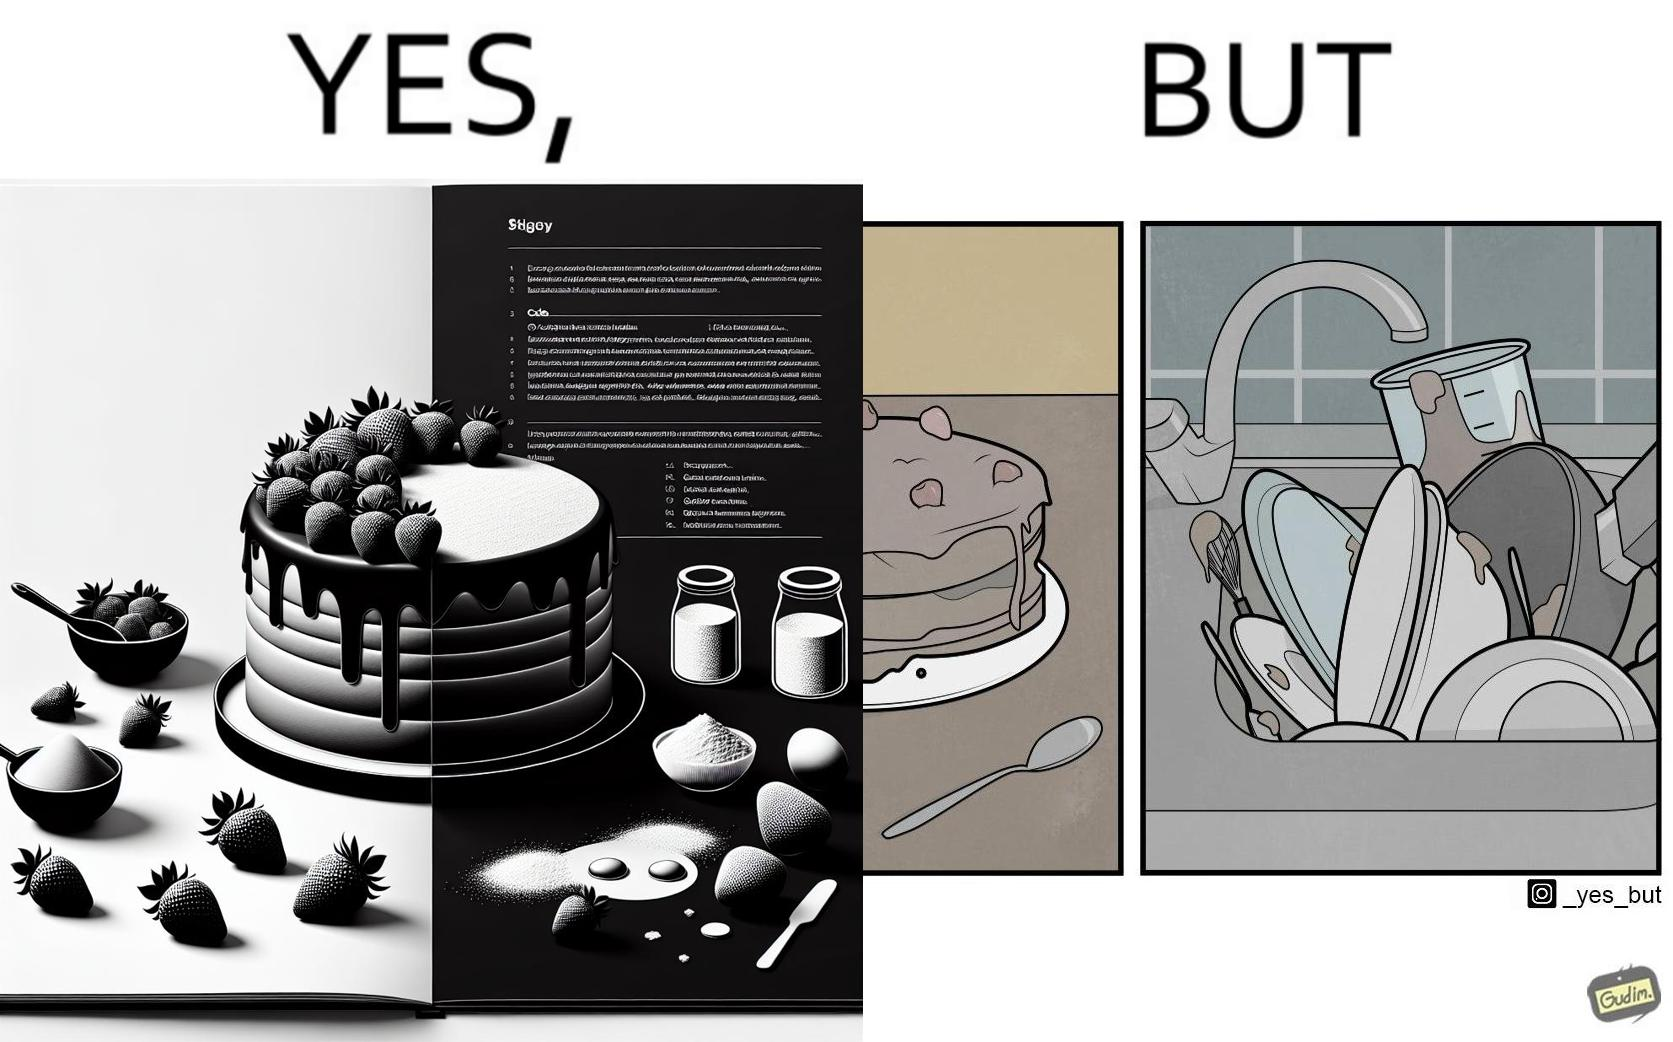What do you see in each half of this image? In the left part of the image: a page of a book showing the image of a strawberry cake, along with its ingredients. In the right part of the image: a cake on a plate, along with a bunch of used utensils to be washed. 